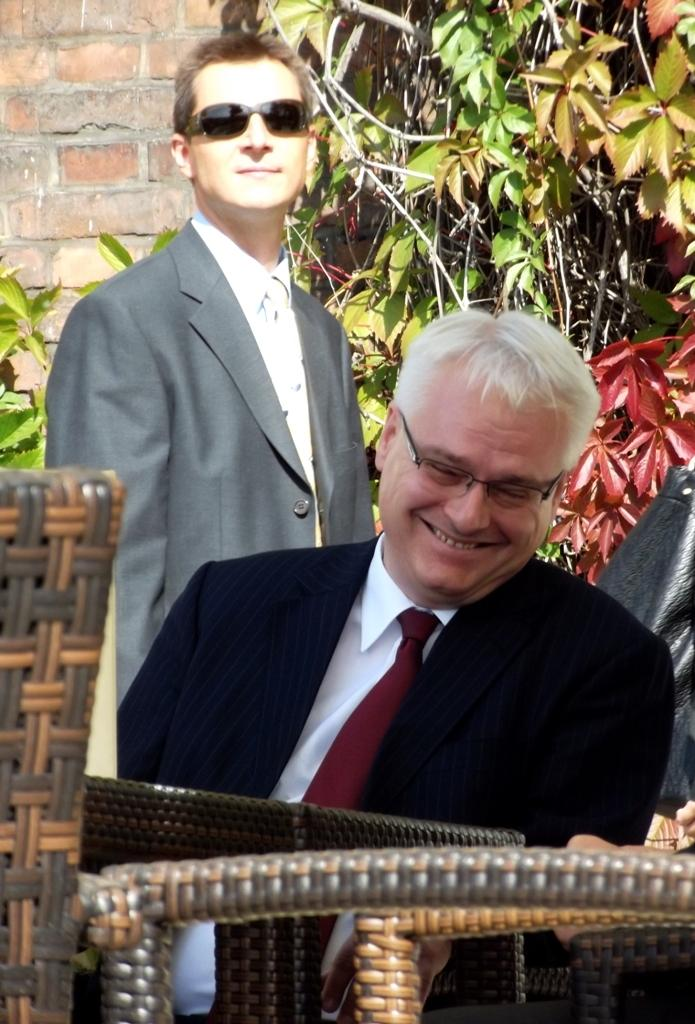How many men are in the image? There are two men in the image. What is one of the men doing in the image? One of the men is sitting and smiling. What do both men have in common? Both men are wearing spectacles and coats. What can be seen in the background of the image? There are plants and a wall in the background of the image. What causes the snow to start falling in the image? There is no snow present in the image, so it cannot start falling. 